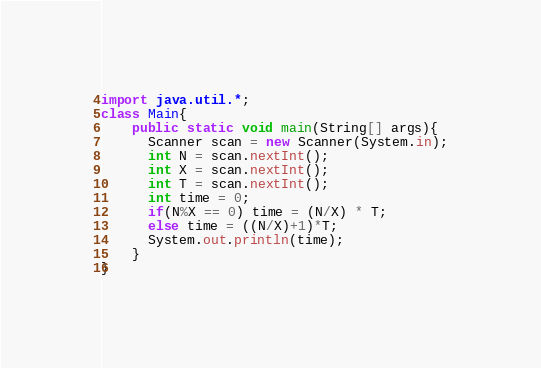<code> <loc_0><loc_0><loc_500><loc_500><_Java_>import java.util.*;
class Main{
	public static void main(String[] args){
	  Scanner scan = new Scanner(System.in);
	  int N = scan.nextInt();
      int X = scan.nextInt();
      int T = scan.nextInt();
      int time = 0;
      if(N%X == 0) time = (N/X) * T;
      else time = ((N/X)+1)*T;
      System.out.println(time);
	}
}</code> 